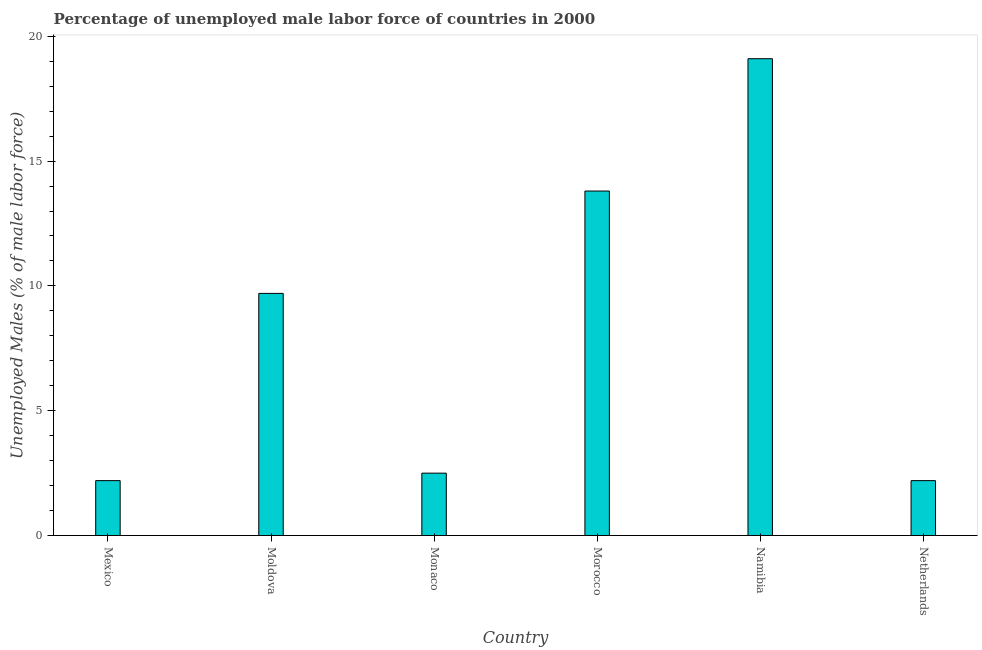Does the graph contain any zero values?
Provide a short and direct response. No. What is the title of the graph?
Give a very brief answer. Percentage of unemployed male labor force of countries in 2000. What is the label or title of the Y-axis?
Make the answer very short. Unemployed Males (% of male labor force). Across all countries, what is the maximum total unemployed male labour force?
Make the answer very short. 19.1. Across all countries, what is the minimum total unemployed male labour force?
Give a very brief answer. 2.2. In which country was the total unemployed male labour force maximum?
Make the answer very short. Namibia. What is the sum of the total unemployed male labour force?
Offer a very short reply. 49.5. What is the difference between the total unemployed male labour force in Moldova and Netherlands?
Offer a very short reply. 7.5. What is the average total unemployed male labour force per country?
Your response must be concise. 8.25. What is the median total unemployed male labour force?
Your answer should be very brief. 6.1. In how many countries, is the total unemployed male labour force greater than 14 %?
Provide a succinct answer. 1. What is the ratio of the total unemployed male labour force in Morocco to that in Netherlands?
Your answer should be compact. 6.27. Is the total unemployed male labour force in Mexico less than that in Namibia?
Offer a terse response. Yes. What is the difference between the highest and the second highest total unemployed male labour force?
Offer a very short reply. 5.3. Is the sum of the total unemployed male labour force in Mexico and Monaco greater than the maximum total unemployed male labour force across all countries?
Your response must be concise. No. What is the difference between the highest and the lowest total unemployed male labour force?
Offer a very short reply. 16.9. How many bars are there?
Your response must be concise. 6. Are all the bars in the graph horizontal?
Offer a very short reply. No. What is the difference between two consecutive major ticks on the Y-axis?
Your answer should be very brief. 5. Are the values on the major ticks of Y-axis written in scientific E-notation?
Offer a very short reply. No. What is the Unemployed Males (% of male labor force) of Mexico?
Your answer should be compact. 2.2. What is the Unemployed Males (% of male labor force) in Moldova?
Ensure brevity in your answer.  9.7. What is the Unemployed Males (% of male labor force) of Monaco?
Make the answer very short. 2.5. What is the Unemployed Males (% of male labor force) in Morocco?
Provide a short and direct response. 13.8. What is the Unemployed Males (% of male labor force) in Namibia?
Make the answer very short. 19.1. What is the Unemployed Males (% of male labor force) of Netherlands?
Your response must be concise. 2.2. What is the difference between the Unemployed Males (% of male labor force) in Mexico and Namibia?
Provide a short and direct response. -16.9. What is the difference between the Unemployed Males (% of male labor force) in Moldova and Monaco?
Offer a very short reply. 7.2. What is the difference between the Unemployed Males (% of male labor force) in Moldova and Namibia?
Make the answer very short. -9.4. What is the difference between the Unemployed Males (% of male labor force) in Moldova and Netherlands?
Make the answer very short. 7.5. What is the difference between the Unemployed Males (% of male labor force) in Monaco and Namibia?
Provide a succinct answer. -16.6. What is the difference between the Unemployed Males (% of male labor force) in Monaco and Netherlands?
Keep it short and to the point. 0.3. What is the ratio of the Unemployed Males (% of male labor force) in Mexico to that in Moldova?
Offer a very short reply. 0.23. What is the ratio of the Unemployed Males (% of male labor force) in Mexico to that in Monaco?
Offer a very short reply. 0.88. What is the ratio of the Unemployed Males (% of male labor force) in Mexico to that in Morocco?
Offer a terse response. 0.16. What is the ratio of the Unemployed Males (% of male labor force) in Mexico to that in Namibia?
Provide a short and direct response. 0.12. What is the ratio of the Unemployed Males (% of male labor force) in Moldova to that in Monaco?
Ensure brevity in your answer.  3.88. What is the ratio of the Unemployed Males (% of male labor force) in Moldova to that in Morocco?
Your answer should be very brief. 0.7. What is the ratio of the Unemployed Males (% of male labor force) in Moldova to that in Namibia?
Offer a very short reply. 0.51. What is the ratio of the Unemployed Males (% of male labor force) in Moldova to that in Netherlands?
Keep it short and to the point. 4.41. What is the ratio of the Unemployed Males (% of male labor force) in Monaco to that in Morocco?
Give a very brief answer. 0.18. What is the ratio of the Unemployed Males (% of male labor force) in Monaco to that in Namibia?
Your response must be concise. 0.13. What is the ratio of the Unemployed Males (% of male labor force) in Monaco to that in Netherlands?
Provide a succinct answer. 1.14. What is the ratio of the Unemployed Males (% of male labor force) in Morocco to that in Namibia?
Offer a terse response. 0.72. What is the ratio of the Unemployed Males (% of male labor force) in Morocco to that in Netherlands?
Your response must be concise. 6.27. What is the ratio of the Unemployed Males (% of male labor force) in Namibia to that in Netherlands?
Provide a short and direct response. 8.68. 